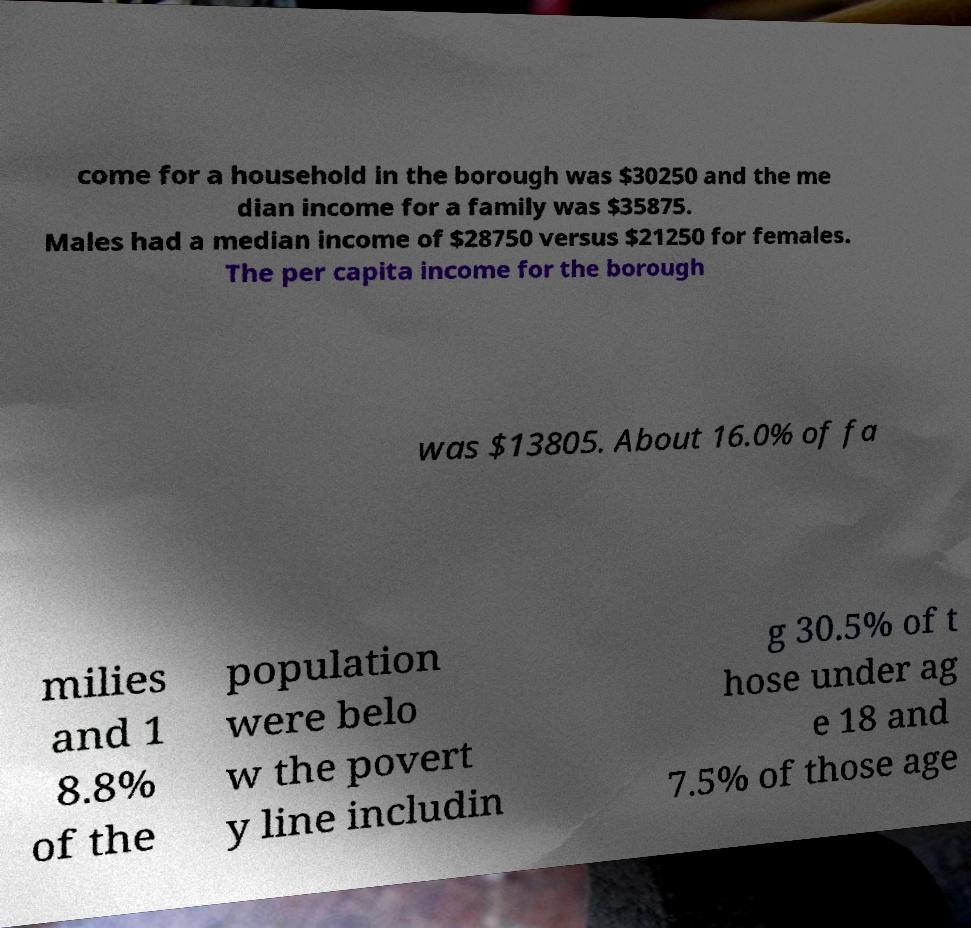I need the written content from this picture converted into text. Can you do that? come for a household in the borough was $30250 and the me dian income for a family was $35875. Males had a median income of $28750 versus $21250 for females. The per capita income for the borough was $13805. About 16.0% of fa milies and 1 8.8% of the population were belo w the povert y line includin g 30.5% of t hose under ag e 18 and 7.5% of those age 